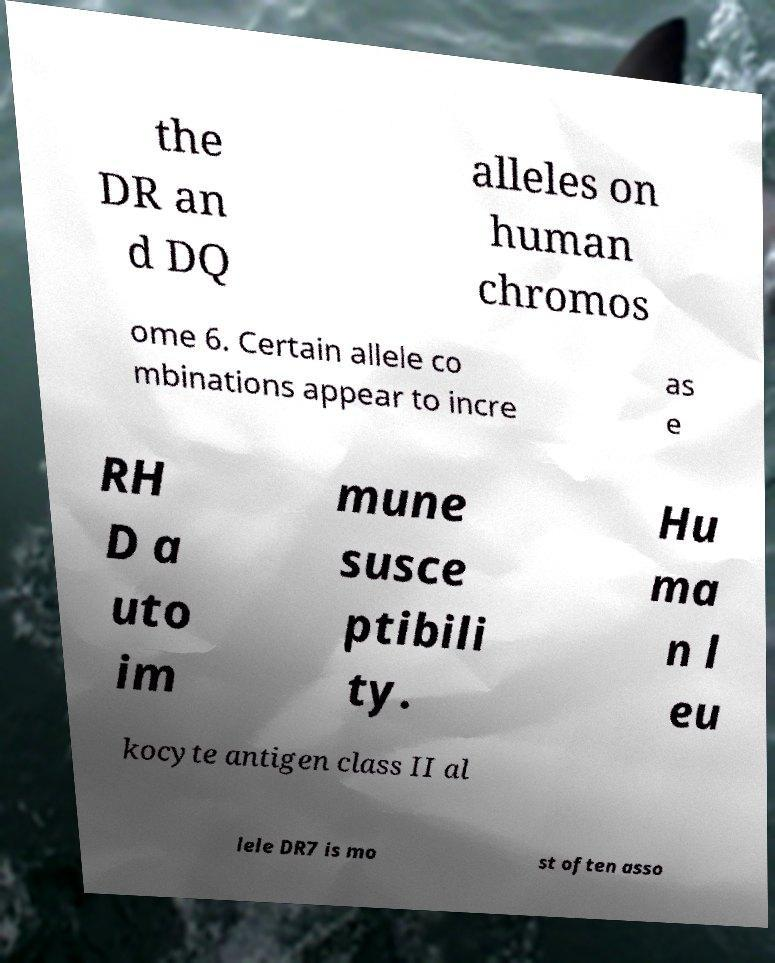I need the written content from this picture converted into text. Can you do that? the DR an d DQ alleles on human chromos ome 6. Certain allele co mbinations appear to incre as e RH D a uto im mune susce ptibili ty. Hu ma n l eu kocyte antigen class II al lele DR7 is mo st often asso 